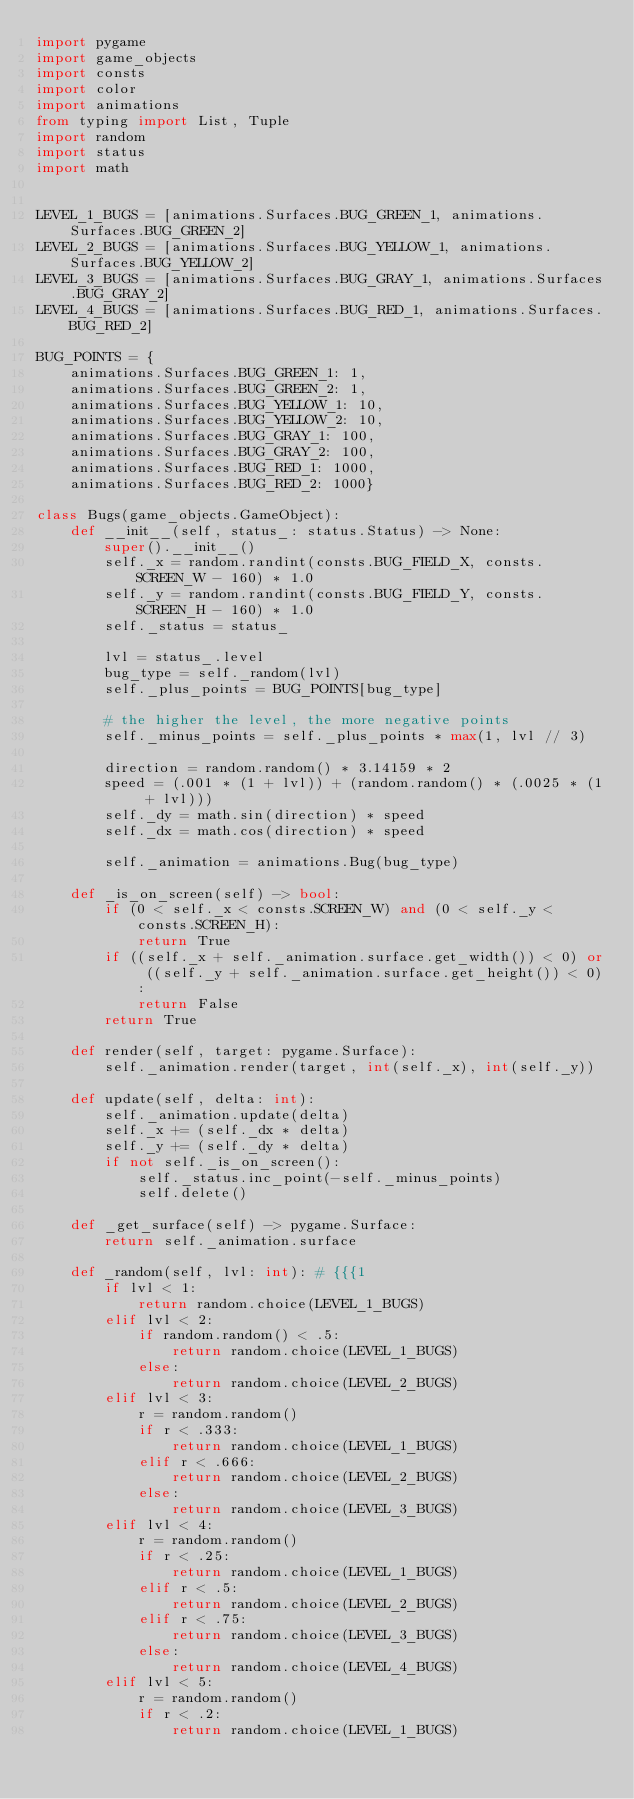<code> <loc_0><loc_0><loc_500><loc_500><_Python_>import pygame
import game_objects
import consts
import color
import animations
from typing import List, Tuple
import random
import status
import math


LEVEL_1_BUGS = [animations.Surfaces.BUG_GREEN_1, animations.Surfaces.BUG_GREEN_2]
LEVEL_2_BUGS = [animations.Surfaces.BUG_YELLOW_1, animations.Surfaces.BUG_YELLOW_2]
LEVEL_3_BUGS = [animations.Surfaces.BUG_GRAY_1, animations.Surfaces.BUG_GRAY_2]
LEVEL_4_BUGS = [animations.Surfaces.BUG_RED_1, animations.Surfaces.BUG_RED_2]

BUG_POINTS = {
    animations.Surfaces.BUG_GREEN_1: 1,
    animations.Surfaces.BUG_GREEN_2: 1,
    animations.Surfaces.BUG_YELLOW_1: 10,
    animations.Surfaces.BUG_YELLOW_2: 10,
    animations.Surfaces.BUG_GRAY_1: 100,
    animations.Surfaces.BUG_GRAY_2: 100,
    animations.Surfaces.BUG_RED_1: 1000,
    animations.Surfaces.BUG_RED_2: 1000}

class Bugs(game_objects.GameObject):
    def __init__(self, status_: status.Status) -> None:
        super().__init__()
        self._x = random.randint(consts.BUG_FIELD_X, consts.SCREEN_W - 160) * 1.0
        self._y = random.randint(consts.BUG_FIELD_Y, consts.SCREEN_H - 160) * 1.0
        self._status = status_

        lvl = status_.level
        bug_type = self._random(lvl)
        self._plus_points = BUG_POINTS[bug_type]

        # the higher the level, the more negative points
        self._minus_points = self._plus_points * max(1, lvl // 3)

        direction = random.random() * 3.14159 * 2
        speed = (.001 * (1 + lvl)) + (random.random() * (.0025 * (1 + lvl)))
        self._dy = math.sin(direction) * speed
        self._dx = math.cos(direction) * speed

        self._animation = animations.Bug(bug_type)

    def _is_on_screen(self) -> bool:
        if (0 < self._x < consts.SCREEN_W) and (0 < self._y < consts.SCREEN_H):
            return True
        if ((self._x + self._animation.surface.get_width()) < 0) or ((self._y + self._animation.surface.get_height()) < 0):
            return False
        return True

    def render(self, target: pygame.Surface):
        self._animation.render(target, int(self._x), int(self._y))

    def update(self, delta: int):
        self._animation.update(delta)
        self._x += (self._dx * delta)
        self._y += (self._dy * delta)
        if not self._is_on_screen():
            self._status.inc_point(-self._minus_points)
            self.delete()

    def _get_surface(self) -> pygame.Surface:
        return self._animation.surface

    def _random(self, lvl: int): # {{{1
        if lvl < 1:
            return random.choice(LEVEL_1_BUGS)
        elif lvl < 2:
            if random.random() < .5:
                return random.choice(LEVEL_1_BUGS)
            else:
                return random.choice(LEVEL_2_BUGS)
        elif lvl < 3:
            r = random.random()
            if r < .333:
                return random.choice(LEVEL_1_BUGS)
            elif r < .666:
                return random.choice(LEVEL_2_BUGS)
            else:
                return random.choice(LEVEL_3_BUGS)
        elif lvl < 4:
            r = random.random()
            if r < .25:
                return random.choice(LEVEL_1_BUGS)
            elif r < .5:
                return random.choice(LEVEL_2_BUGS)
            elif r < .75:
                return random.choice(LEVEL_3_BUGS)
            else:
                return random.choice(LEVEL_4_BUGS)
        elif lvl < 5:
            r = random.random()
            if r < .2:
                return random.choice(LEVEL_1_BUGS)</code> 